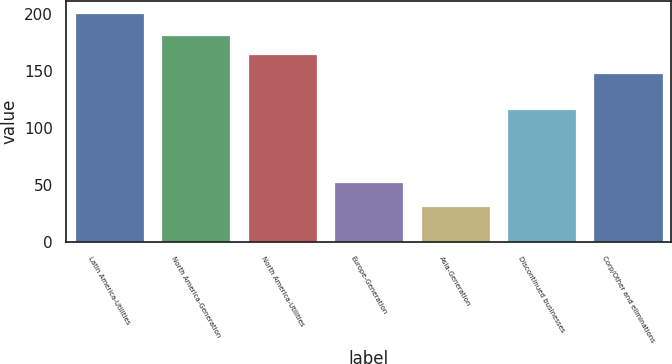<chart> <loc_0><loc_0><loc_500><loc_500><bar_chart><fcel>Latin America-Utilities<fcel>North America-Generation<fcel>North America-Utilities<fcel>Europe-Generation<fcel>Asia-Generation<fcel>Discontinued businesses<fcel>Corp/Other and eliminations<nl><fcel>201<fcel>181.8<fcel>164.9<fcel>53<fcel>32<fcel>117<fcel>148<nl></chart> 